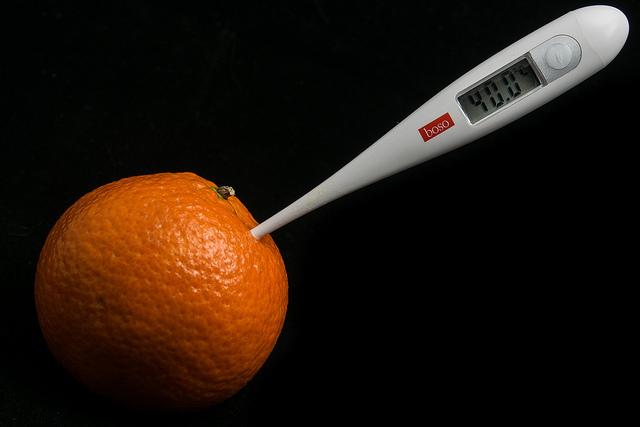Why is there a thermometer in the orange?
Keep it brief. Temperature. What color is the orange?
Be succinct. Orange. Why is the temperature of the orange so high?
Keep it brief. Freshly picked. 